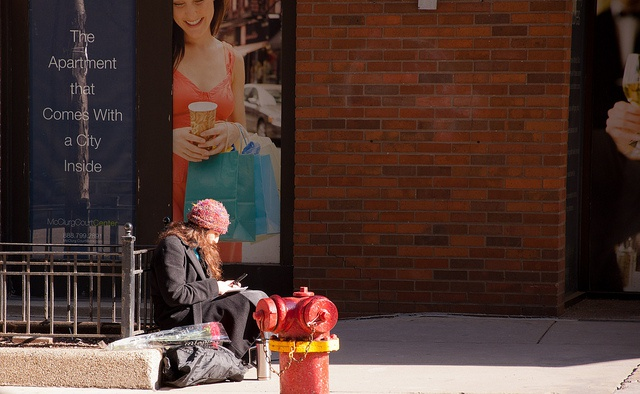Describe the objects in this image and their specific colors. I can see people in black, gray, teal, brown, and maroon tones, people in black, gray, and maroon tones, fire hydrant in black, brown, salmon, and maroon tones, backpack in black, darkgray, gray, and lightgray tones, and people in black, brown, and maroon tones in this image. 